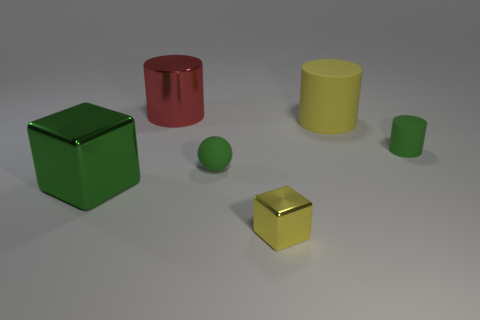If you had to guess, what material do these objects seem to be made of, and why? From the appearance in the image, the objects seem to be made of a smooth, matte material, potentially plastic or a similar synthetic substance. This is inferred from the soft reflections and the way light is diffused across their surfaces. The colors are uniform with no texture, suggesting they are not made of natural materials like wood or stone. 